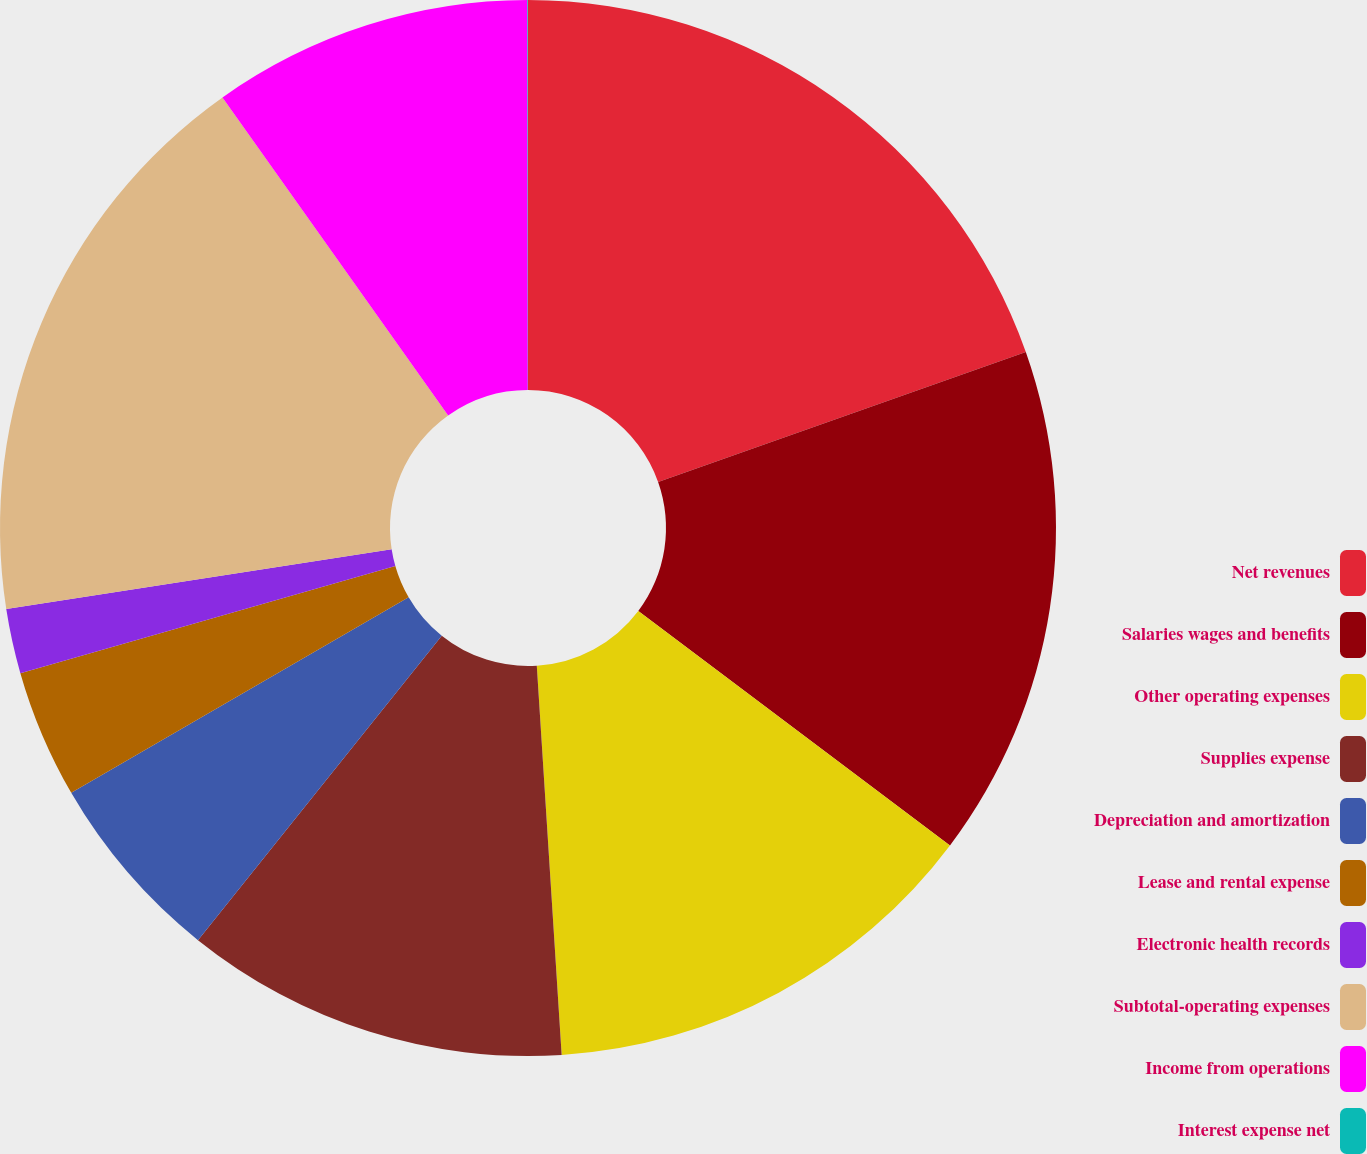Convert chart to OTSL. <chart><loc_0><loc_0><loc_500><loc_500><pie_chart><fcel>Net revenues<fcel>Salaries wages and benefits<fcel>Other operating expenses<fcel>Supplies expense<fcel>Depreciation and amortization<fcel>Lease and rental expense<fcel>Electronic health records<fcel>Subtotal-operating expenses<fcel>Income from operations<fcel>Interest expense net<nl><fcel>19.59%<fcel>15.67%<fcel>13.72%<fcel>11.76%<fcel>5.89%<fcel>3.93%<fcel>1.98%<fcel>17.63%<fcel>9.8%<fcel>0.02%<nl></chart> 